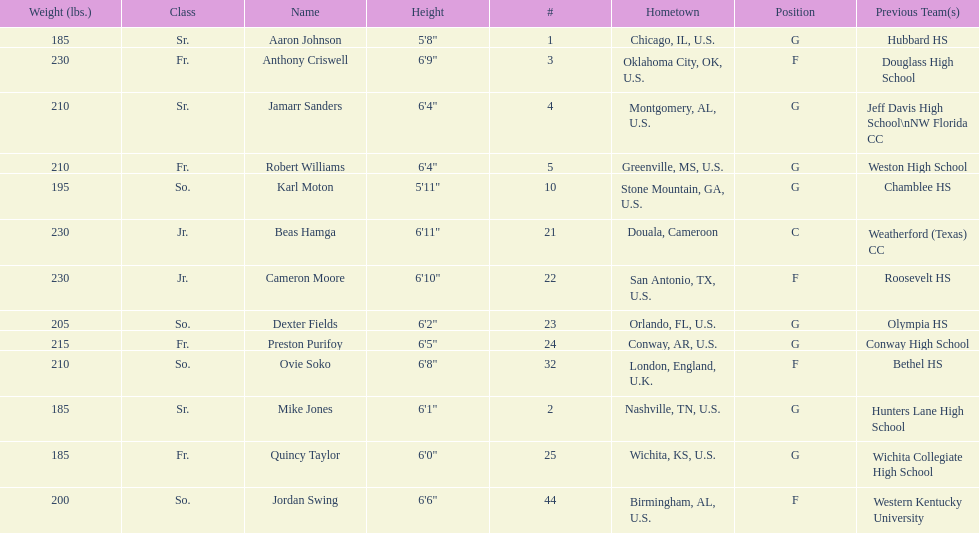What is the difference in weight between dexter fields and quincy taylor? 20. 